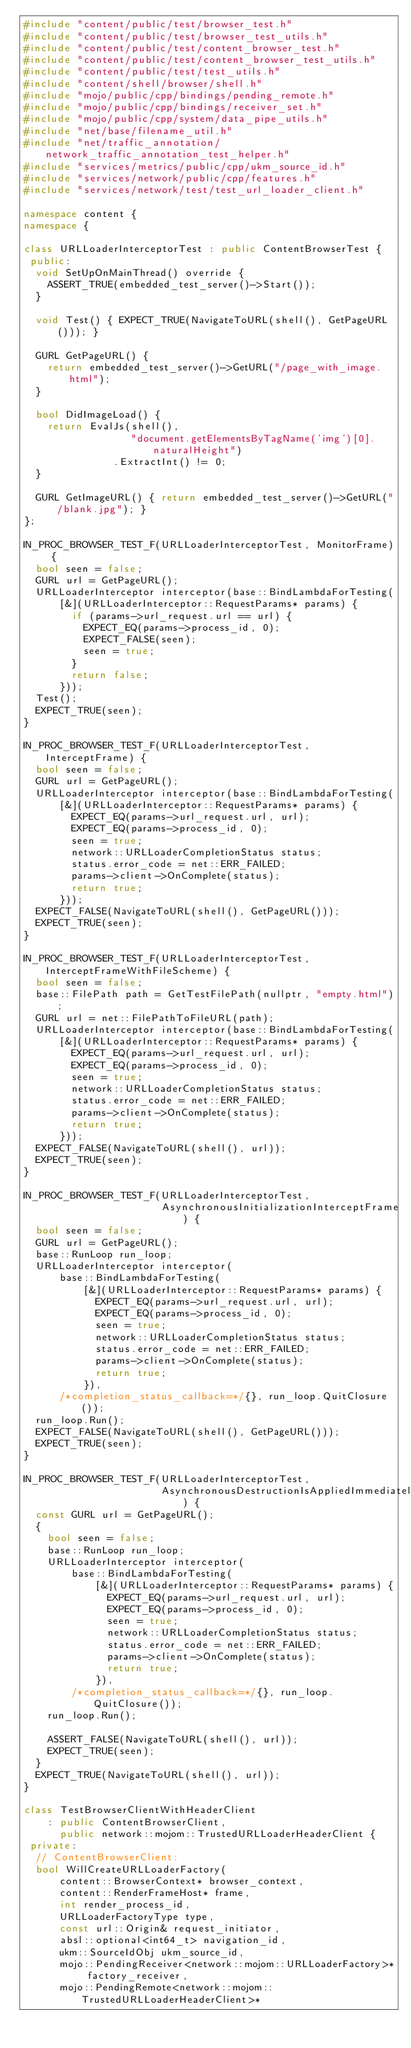<code> <loc_0><loc_0><loc_500><loc_500><_C++_>#include "content/public/test/browser_test.h"
#include "content/public/test/browser_test_utils.h"
#include "content/public/test/content_browser_test.h"
#include "content/public/test/content_browser_test_utils.h"
#include "content/public/test/test_utils.h"
#include "content/shell/browser/shell.h"
#include "mojo/public/cpp/bindings/pending_remote.h"
#include "mojo/public/cpp/bindings/receiver_set.h"
#include "mojo/public/cpp/system/data_pipe_utils.h"
#include "net/base/filename_util.h"
#include "net/traffic_annotation/network_traffic_annotation_test_helper.h"
#include "services/metrics/public/cpp/ukm_source_id.h"
#include "services/network/public/cpp/features.h"
#include "services/network/test/test_url_loader_client.h"

namespace content {
namespace {

class URLLoaderInterceptorTest : public ContentBrowserTest {
 public:
  void SetUpOnMainThread() override {
    ASSERT_TRUE(embedded_test_server()->Start());
  }

  void Test() { EXPECT_TRUE(NavigateToURL(shell(), GetPageURL())); }

  GURL GetPageURL() {
    return embedded_test_server()->GetURL("/page_with_image.html");
  }

  bool DidImageLoad() {
    return EvalJs(shell(),
                  "document.getElementsByTagName('img')[0].naturalHeight")
               .ExtractInt() != 0;
  }

  GURL GetImageURL() { return embedded_test_server()->GetURL("/blank.jpg"); }
};

IN_PROC_BROWSER_TEST_F(URLLoaderInterceptorTest, MonitorFrame) {
  bool seen = false;
  GURL url = GetPageURL();
  URLLoaderInterceptor interceptor(base::BindLambdaForTesting(
      [&](URLLoaderInterceptor::RequestParams* params) {
        if (params->url_request.url == url) {
          EXPECT_EQ(params->process_id, 0);
          EXPECT_FALSE(seen);
          seen = true;
        }
        return false;
      }));
  Test();
  EXPECT_TRUE(seen);
}

IN_PROC_BROWSER_TEST_F(URLLoaderInterceptorTest, InterceptFrame) {
  bool seen = false;
  GURL url = GetPageURL();
  URLLoaderInterceptor interceptor(base::BindLambdaForTesting(
      [&](URLLoaderInterceptor::RequestParams* params) {
        EXPECT_EQ(params->url_request.url, url);
        EXPECT_EQ(params->process_id, 0);
        seen = true;
        network::URLLoaderCompletionStatus status;
        status.error_code = net::ERR_FAILED;
        params->client->OnComplete(status);
        return true;
      }));
  EXPECT_FALSE(NavigateToURL(shell(), GetPageURL()));
  EXPECT_TRUE(seen);
}

IN_PROC_BROWSER_TEST_F(URLLoaderInterceptorTest, InterceptFrameWithFileScheme) {
  bool seen = false;
  base::FilePath path = GetTestFilePath(nullptr, "empty.html");
  GURL url = net::FilePathToFileURL(path);
  URLLoaderInterceptor interceptor(base::BindLambdaForTesting(
      [&](URLLoaderInterceptor::RequestParams* params) {
        EXPECT_EQ(params->url_request.url, url);
        EXPECT_EQ(params->process_id, 0);
        seen = true;
        network::URLLoaderCompletionStatus status;
        status.error_code = net::ERR_FAILED;
        params->client->OnComplete(status);
        return true;
      }));
  EXPECT_FALSE(NavigateToURL(shell(), url));
  EXPECT_TRUE(seen);
}

IN_PROC_BROWSER_TEST_F(URLLoaderInterceptorTest,
                       AsynchronousInitializationInterceptFrame) {
  bool seen = false;
  GURL url = GetPageURL();
  base::RunLoop run_loop;
  URLLoaderInterceptor interceptor(
      base::BindLambdaForTesting(
          [&](URLLoaderInterceptor::RequestParams* params) {
            EXPECT_EQ(params->url_request.url, url);
            EXPECT_EQ(params->process_id, 0);
            seen = true;
            network::URLLoaderCompletionStatus status;
            status.error_code = net::ERR_FAILED;
            params->client->OnComplete(status);
            return true;
          }),
      /*completion_status_callback=*/{}, run_loop.QuitClosure());
  run_loop.Run();
  EXPECT_FALSE(NavigateToURL(shell(), GetPageURL()));
  EXPECT_TRUE(seen);
}

IN_PROC_BROWSER_TEST_F(URLLoaderInterceptorTest,
                       AsynchronousDestructionIsAppliedImmediately) {
  const GURL url = GetPageURL();
  {
    bool seen = false;
    base::RunLoop run_loop;
    URLLoaderInterceptor interceptor(
        base::BindLambdaForTesting(
            [&](URLLoaderInterceptor::RequestParams* params) {
              EXPECT_EQ(params->url_request.url, url);
              EXPECT_EQ(params->process_id, 0);
              seen = true;
              network::URLLoaderCompletionStatus status;
              status.error_code = net::ERR_FAILED;
              params->client->OnComplete(status);
              return true;
            }),
        /*completion_status_callback=*/{}, run_loop.QuitClosure());
    run_loop.Run();

    ASSERT_FALSE(NavigateToURL(shell(), url));
    EXPECT_TRUE(seen);
  }
  EXPECT_TRUE(NavigateToURL(shell(), url));
}

class TestBrowserClientWithHeaderClient
    : public ContentBrowserClient,
      public network::mojom::TrustedURLLoaderHeaderClient {
 private:
  // ContentBrowserClient:
  bool WillCreateURLLoaderFactory(
      content::BrowserContext* browser_context,
      content::RenderFrameHost* frame,
      int render_process_id,
      URLLoaderFactoryType type,
      const url::Origin& request_initiator,
      absl::optional<int64_t> navigation_id,
      ukm::SourceIdObj ukm_source_id,
      mojo::PendingReceiver<network::mojom::URLLoaderFactory>* factory_receiver,
      mojo::PendingRemote<network::mojom::TrustedURLLoaderHeaderClient>*</code> 